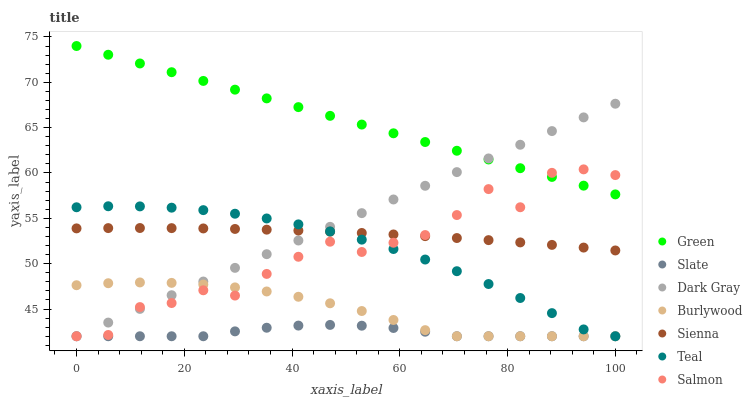Does Slate have the minimum area under the curve?
Answer yes or no. Yes. Does Green have the maximum area under the curve?
Answer yes or no. Yes. Does Burlywood have the minimum area under the curve?
Answer yes or no. No. Does Burlywood have the maximum area under the curve?
Answer yes or no. No. Is Dark Gray the smoothest?
Answer yes or no. Yes. Is Salmon the roughest?
Answer yes or no. Yes. Is Burlywood the smoothest?
Answer yes or no. No. Is Burlywood the roughest?
Answer yes or no. No. Does Burlywood have the lowest value?
Answer yes or no. Yes. Does Green have the lowest value?
Answer yes or no. No. Does Green have the highest value?
Answer yes or no. Yes. Does Burlywood have the highest value?
Answer yes or no. No. Is Burlywood less than Green?
Answer yes or no. Yes. Is Green greater than Slate?
Answer yes or no. Yes. Does Green intersect Salmon?
Answer yes or no. Yes. Is Green less than Salmon?
Answer yes or no. No. Is Green greater than Salmon?
Answer yes or no. No. Does Burlywood intersect Green?
Answer yes or no. No. 